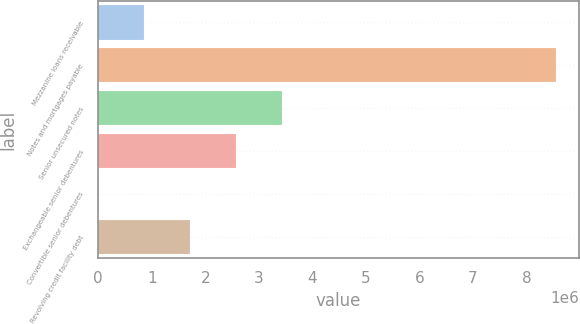<chart> <loc_0><loc_0><loc_500><loc_500><bar_chart><fcel>Mezzanine loans receivable<fcel>Notes and mortgages payable<fcel>Senior unsecured notes<fcel>Exchangeable senior debentures<fcel>Convertible senior debentures<fcel>Revolving credit facility debt<nl><fcel>864979<fcel>8.55828e+06<fcel>3.42941e+06<fcel>2.5746e+06<fcel>10168<fcel>1.71979e+06<nl></chart> 